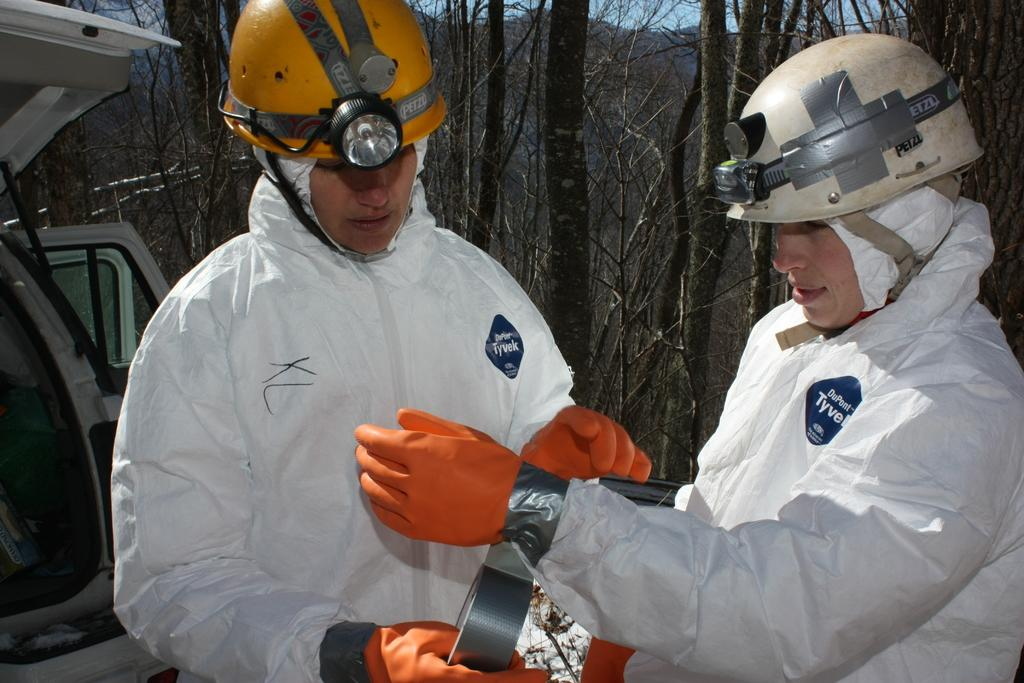How many people are in the image? There are two people standing in the image. What are the people wearing? The people are wearing safety caps, lights, gloves, and white dresses. What can be seen in the background of the image? There appears to be a vehicle and trees with branches visible in the image. What type of protest is happening in the image? There is no protest visible in the image. Can you tell me which knee is injured on the person standing on the left? There is no mention of an injured knee or any injuries in the image. 